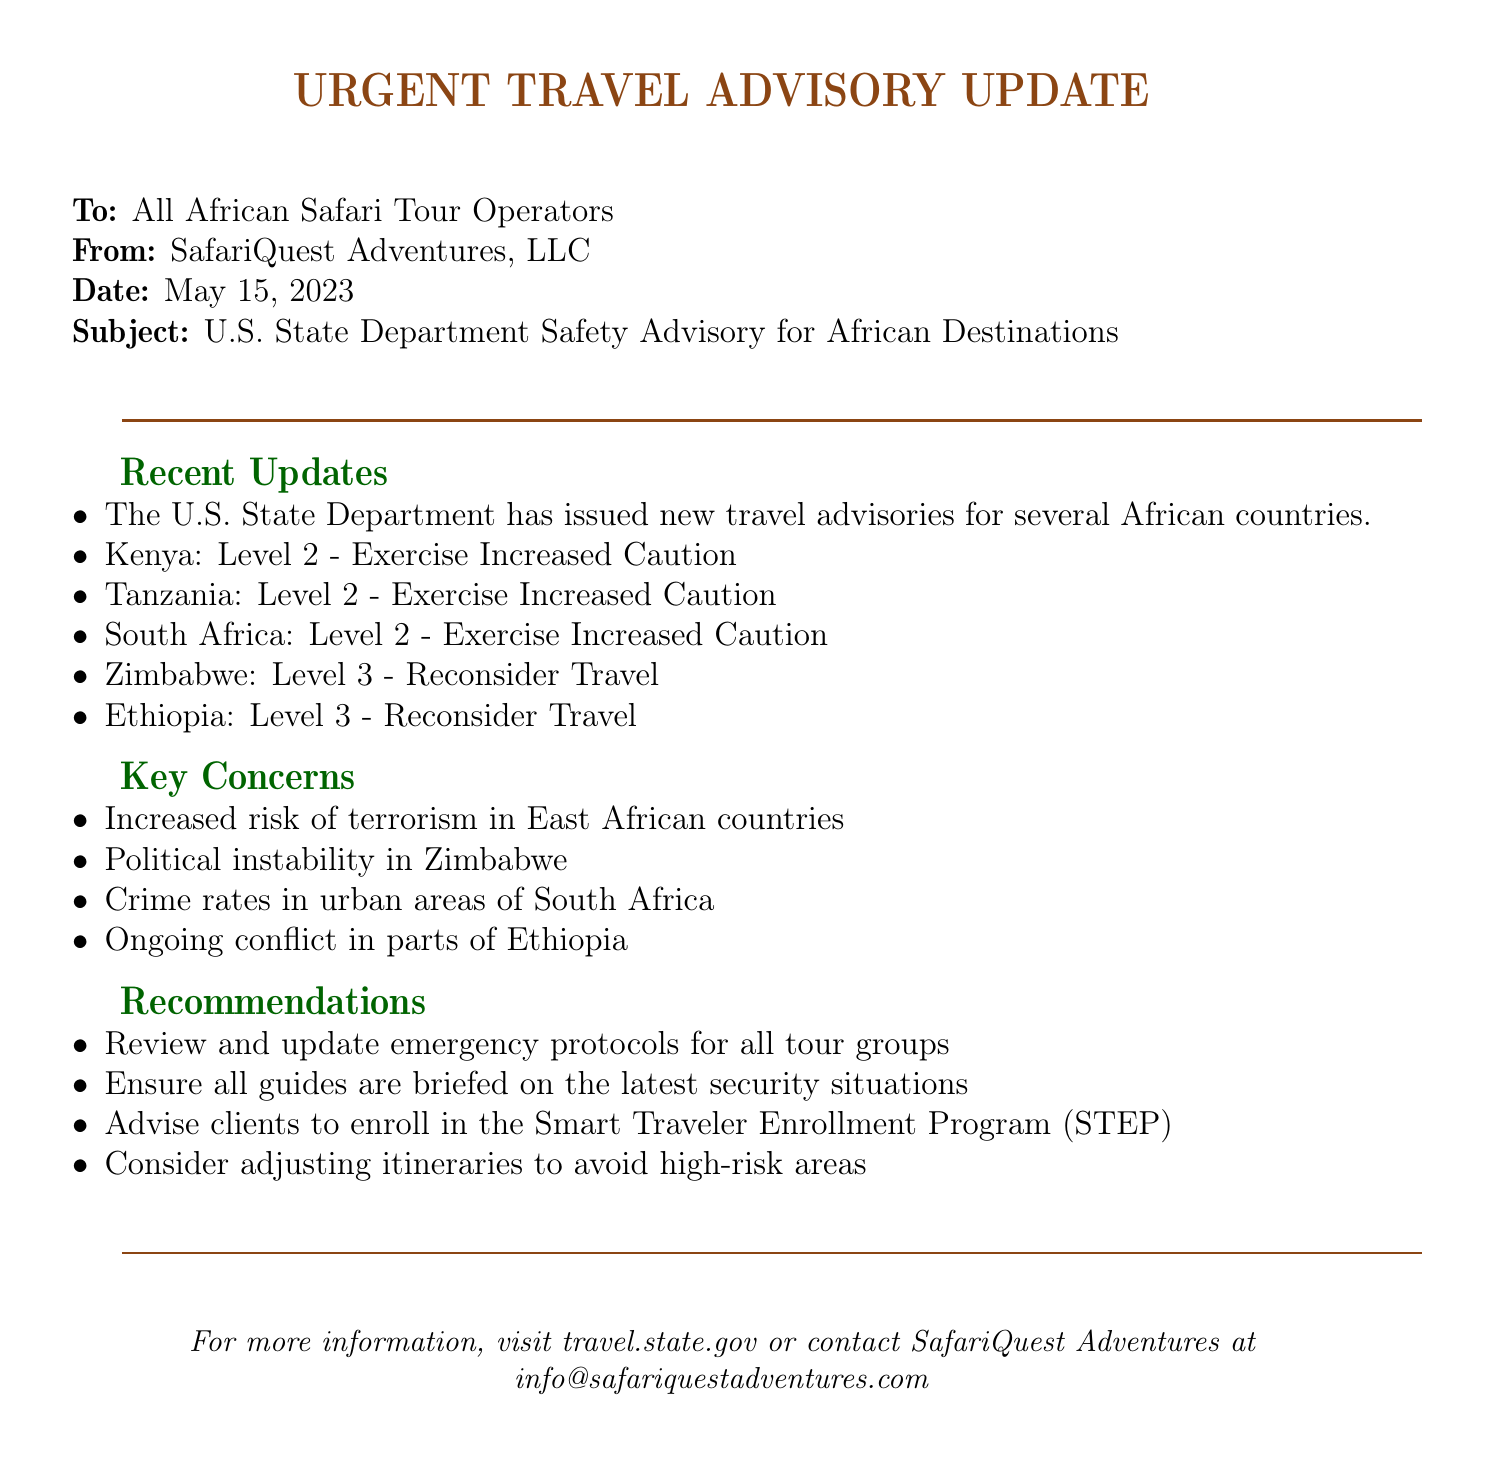What is the date of the advisory? The advisory was dated May 15, 2023, as stated in the document.
Answer: May 15, 2023 What level of caution is advised for South Africa? The advisory indicates that South Africa has a Level 2 advisory, which is to Exercise Increased Caution.
Answer: Level 2 - Exercise Increased Caution What is the recommended action for clients? The document recommends that clients enroll in the Smart Traveler Enrollment Program (STEP).
Answer: Enroll in STEP Which country is marked with a Level 3 advisory? The countries Zimbabwe and Ethiopia are both marked with a Level 3 advisory indicating to Reconsider Travel.
Answer: Zimbabwe, Ethiopia What is a key concern regarding Kenya? The advisory highlights increased risk of terrorism in East African countries, which includes Kenya.
Answer: Increased risk of terrorism What should tour operators do regarding emergency protocols? Tour operators are recommended to review and update emergency protocols for all tour groups.
Answer: Review and update emergency protocols What organization issued the travel advisory? The travel advisory was issued by the U.S. State Department.
Answer: U.S. State Department Which email address is provided for more information? The document provides an email address for inquiries: info@safariquestadventures.com.
Answer: info@safariquestadventures.com What is the main purpose of the document? The main purpose of the document is to provide an urgent travel advisory update regarding safety for African destinations.
Answer: Urgent travel advisory update 